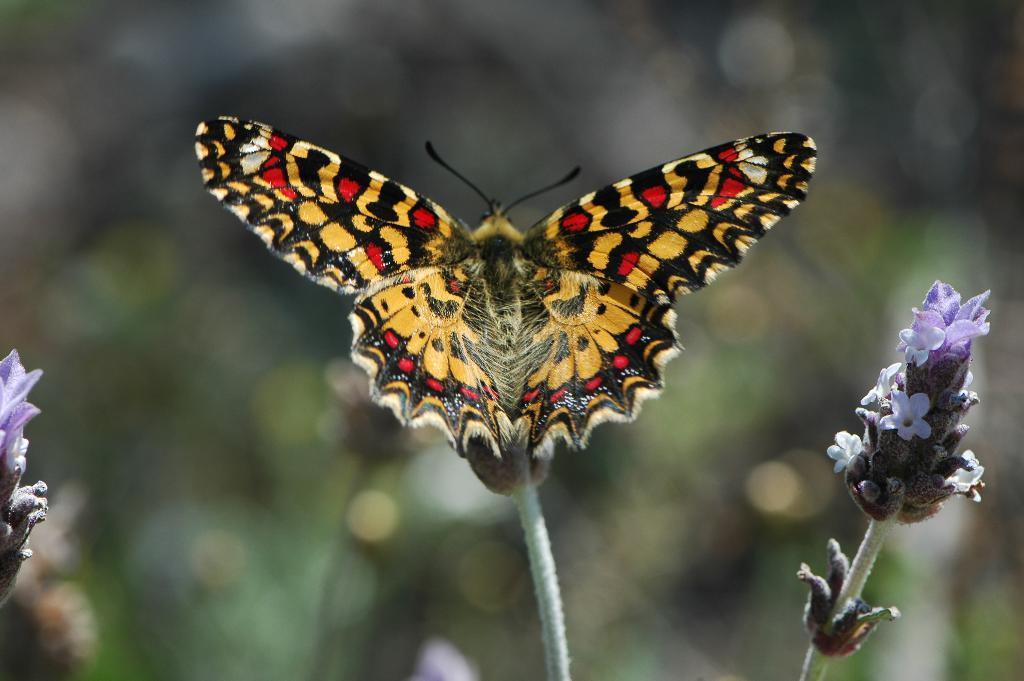Describe this image in one or two sentences. In this image we can see a flower of a plant, above the flower there is a butterfly. 